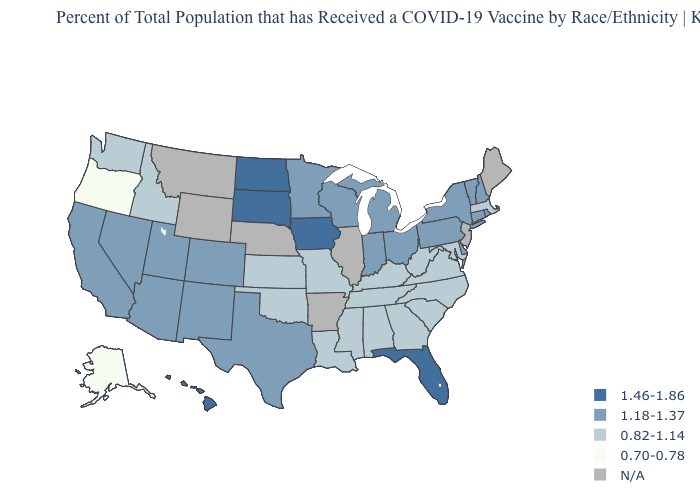What is the highest value in the Northeast ?
Write a very short answer. 1.18-1.37. Does the first symbol in the legend represent the smallest category?
Keep it brief. No. Is the legend a continuous bar?
Concise answer only. No. What is the lowest value in states that border North Dakota?
Answer briefly. 1.18-1.37. Does the first symbol in the legend represent the smallest category?
Give a very brief answer. No. Which states hav the highest value in the West?
Write a very short answer. Hawaii. Does the map have missing data?
Keep it brief. Yes. What is the highest value in the USA?
Keep it brief. 1.46-1.86. Which states hav the highest value in the MidWest?
Be succinct. Iowa, North Dakota, South Dakota. Name the states that have a value in the range 1.18-1.37?
Short answer required. Arizona, California, Colorado, Connecticut, Delaware, Indiana, Michigan, Minnesota, Nevada, New Hampshire, New Mexico, New York, Ohio, Pennsylvania, Rhode Island, Texas, Utah, Vermont, Wisconsin. What is the highest value in the USA?
Concise answer only. 1.46-1.86. What is the highest value in states that border Arizona?
Concise answer only. 1.18-1.37. 